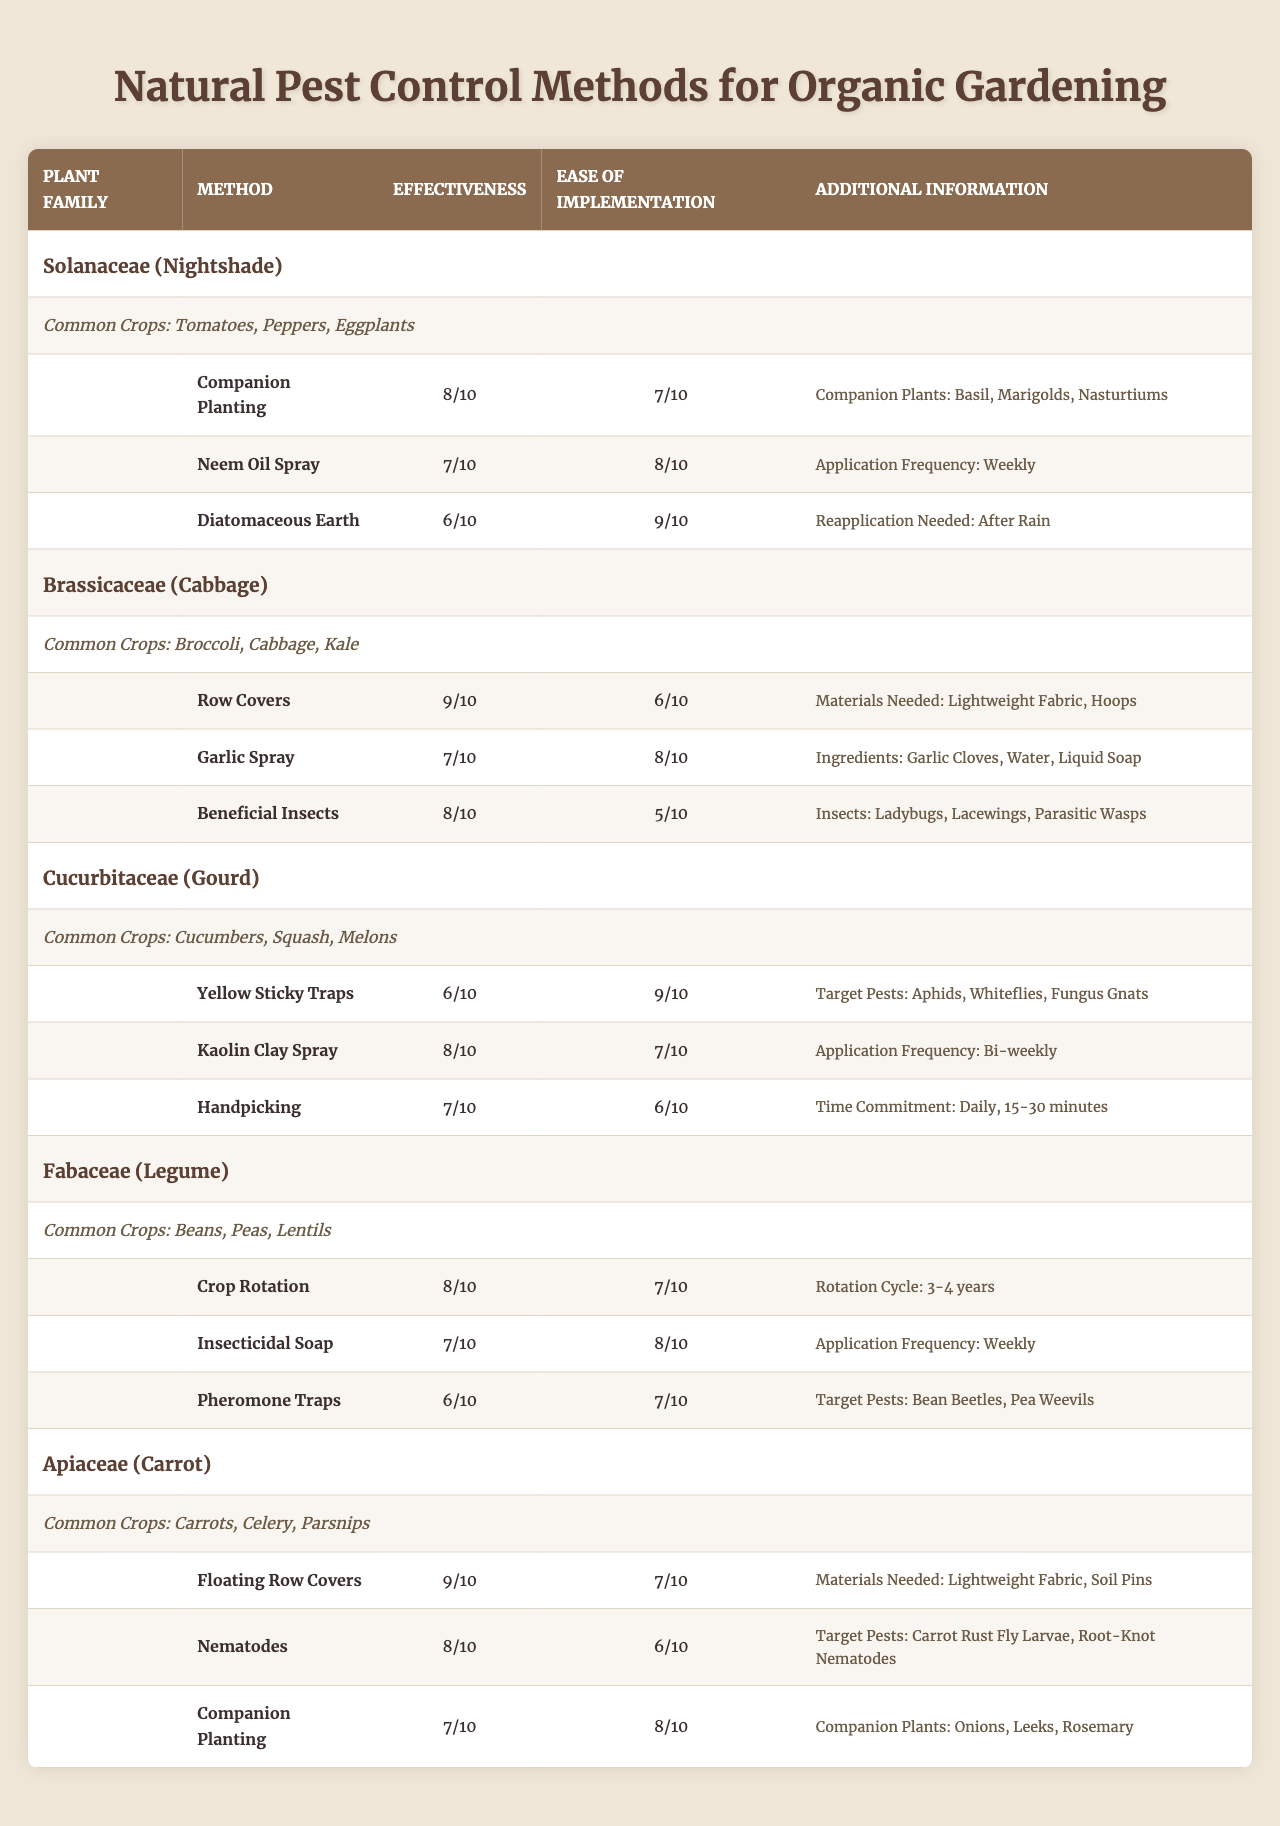What's the effectiveness rating of the "Row Covers" method for the Brassicaceae family? The effectiveness rating is found under the "Effectiveness" column for the "Row Covers" method listed under the Brassicaceae family, which is 9 out of 10.
Answer: 9 What is the ease of implementation rating for "Neem Oil Spray" under the Solanaceae family? The ease of implementation rating for "Neem Oil Spray" is located in the "Ease of Implementation" column for the Solanaceae family, where it is rated 8 out of 10.
Answer: 8 Which pest control method has the highest effectiveness in the Apiaceae family? The effectiveness ratings for the methods in the Apiaceae family are as follows: Floating Row Covers (9), Nematodes (8), and Companion Planting (7). The highest rating is 9 for Floating Row Covers.
Answer: Floating Row Covers What is the average effectiveness rating of pest control methods in the Cucurbitaceae family? The effectiveness ratings for Cucurbitaceae methods are: Yellow Sticky Traps (6), Kaolin Clay Spray (8), and Handpicking (7). Calculating the average: (6 + 8 + 7) / 3 = 21 / 3 = 7.
Answer: 7 Is "Garlic Spray" easier to implement than "Diatomaceous Earth"? For "Garlic Spray" the ease of implementation is rated 8, while "Diatomaceous Earth" has an ease rating of 9. Since 8 is not greater than 9, the statement is false.
Answer: No Which plant family has the pest control method "Handpicking"? The method "Handpicking" is listed under the Cucurbitaceae family, as indicated in the "Pest Control Methods" section.
Answer: Cucurbitaceae What is the target pest for "Pheromone Traps" in the Fabaceae family? The "Pheromone Traps" method is in the Fabaceae family, and the target pests listed are Bean Beetles and Pea Weevils.
Answer: Bean Beetles, Pea Weevils If you compare the ease of implementation of methods from the Fabaceae and Apiaceae families, which family has a higher average? For Fabaceae, the ease ratings are 7 (Crop Rotation), 8 (Insecticidal Soap), and 7 (Pheromone Traps); average = (7 + 8 + 7)/3 = 7.67. For Apiaceae: 7 (Floating Row Covers), 6 (Nematodes), and 8 (Companion Planting); average = (7 + 6 + 8)/3 = 7. Therefore, Fabaceae has a higher average.
Answer: Fabaceae Which companion plants are suggested for the "Companion Planting" method in the Solanaceae family? The Companion Plants for the "Companion Planting" method in the Solanaceae family are Basil, Marigolds, and Nasturtiums, as listed in the additional information column for that method.
Answer: Basil, Marigolds, Nasturtiums Does the "Kaolin Clay Spray" method require a specific application frequency? Yes, it specifies an application frequency of Bi-weekly, indicated in the additional information for the Kaolin Clay Spray method under the Cucurbitaceae family.
Answer: Yes 